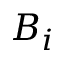Convert formula to latex. <formula><loc_0><loc_0><loc_500><loc_500>B _ { i }</formula> 